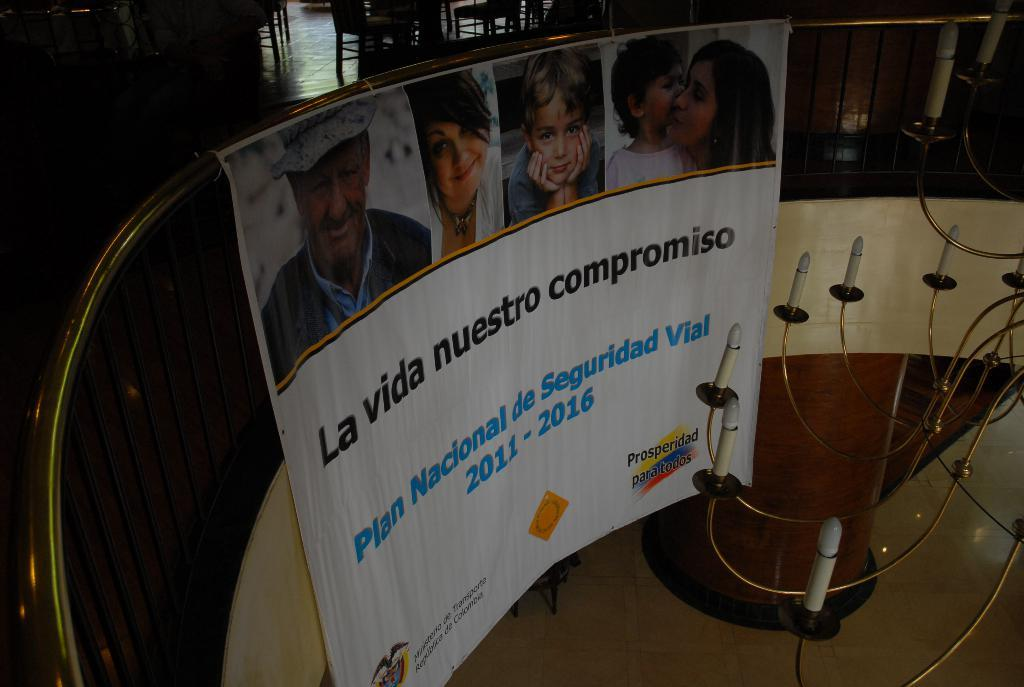What is the main subject of the image? The main subject of the image is a fencing. What can be seen on the fencing? The fencing has pictures of people on it and there is writing on the fencing. What else can be observed in the image? There are lights visible in the image. What time of day is the plantation being harvested in the image? There is no plantation or harvesting activity present in the image; it features a fencing with pictures of people and writing. What is the source of the surprise in the image? There is no surprise or any indication of surprise in the image; it simply shows a fencing with pictures of people, writing, and lights. 